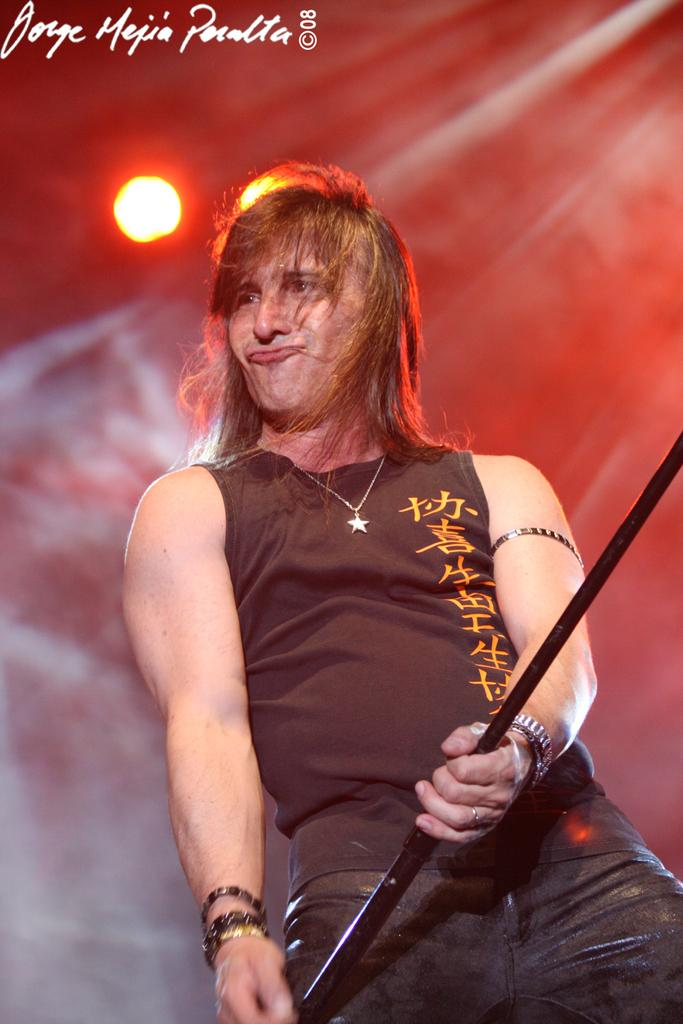What is the main subject of the image? There is a man in the image. What is the man holding in his hand? The man is holding a metal rod in his hand. What can be seen in the background of the image? There are lights in the background of the image. What type of grip does the man have on the metal rod in the image? There is no information about the man's grip on the metal rod in the image, so it cannot be determined. 